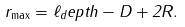Convert formula to latex. <formula><loc_0><loc_0><loc_500><loc_500>r _ { \max } = \ell _ { d } e p t h - D + 2 R .</formula> 